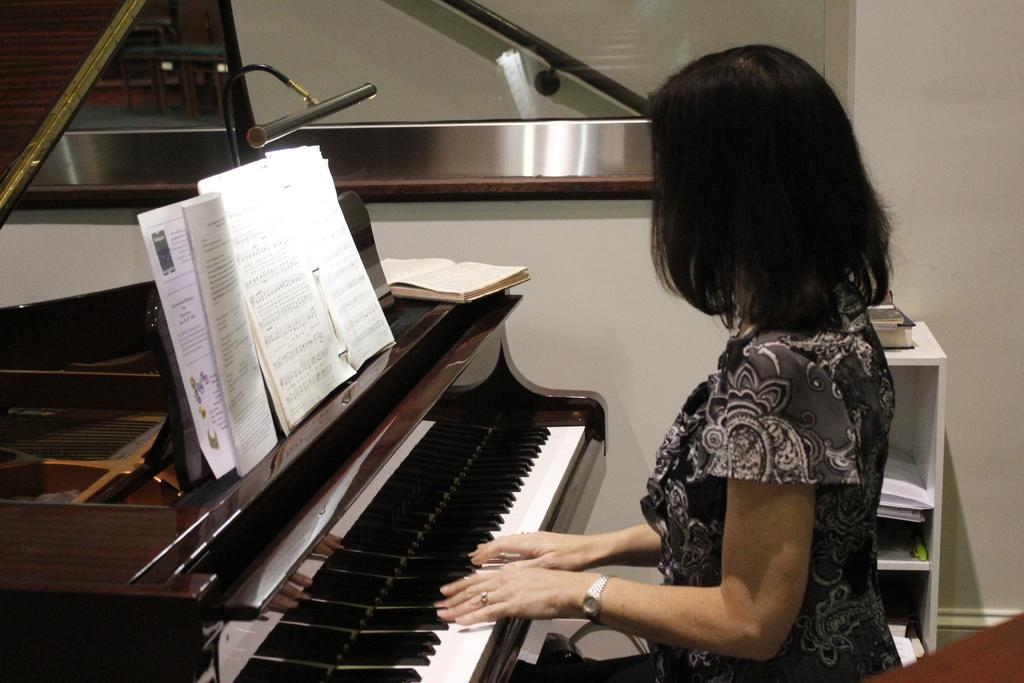Who is present in the image? There is a woman in the image. What is the woman doing in the image? The woman has her hands on a piano. What else can be seen on the piano? There are books on the piano. What can be seen in the background of the image? There is a wall and a rack in the background of the image. What type of stem can be seen growing from the dirt in the image? There is no stem or dirt present in the image; it features a woman playing a piano with books on it and a background with a wall and a rack. 